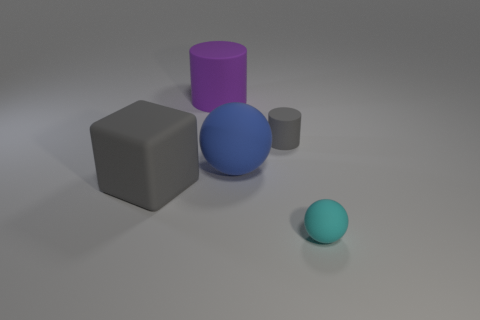Add 2 large rubber balls. How many objects exist? 7 Subtract all spheres. How many objects are left? 3 Subtract all red things. Subtract all tiny gray matte cylinders. How many objects are left? 4 Add 4 tiny gray matte objects. How many tiny gray matte objects are left? 5 Add 1 cyan rubber cylinders. How many cyan rubber cylinders exist? 1 Subtract 0 red cylinders. How many objects are left? 5 